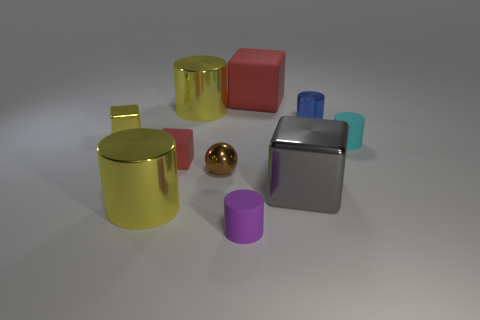Do the large matte object and the small cube in front of the small cyan rubber cylinder have the same color?
Your answer should be compact. Yes. There is a small object that is to the right of the large rubber object and behind the cyan matte object; what color is it?
Give a very brief answer. Blue. What number of other things are there of the same material as the big gray cube
Make the answer very short. 5. Is the number of matte things less than the number of yellow metallic objects?
Provide a short and direct response. No. Are the yellow block and the blue cylinder that is on the right side of the purple matte object made of the same material?
Your response must be concise. Yes. What is the shape of the rubber thing that is on the right side of the large rubber thing?
Keep it short and to the point. Cylinder. Is there any other thing that is the same color as the big matte cube?
Your response must be concise. Yes. Is the number of big gray shiny objects that are in front of the tiny yellow metal cube less than the number of yellow metal cylinders?
Ensure brevity in your answer.  Yes. What number of cyan objects have the same size as the gray metallic thing?
Ensure brevity in your answer.  0. The tiny object that is the same color as the large rubber object is what shape?
Give a very brief answer. Cube. 